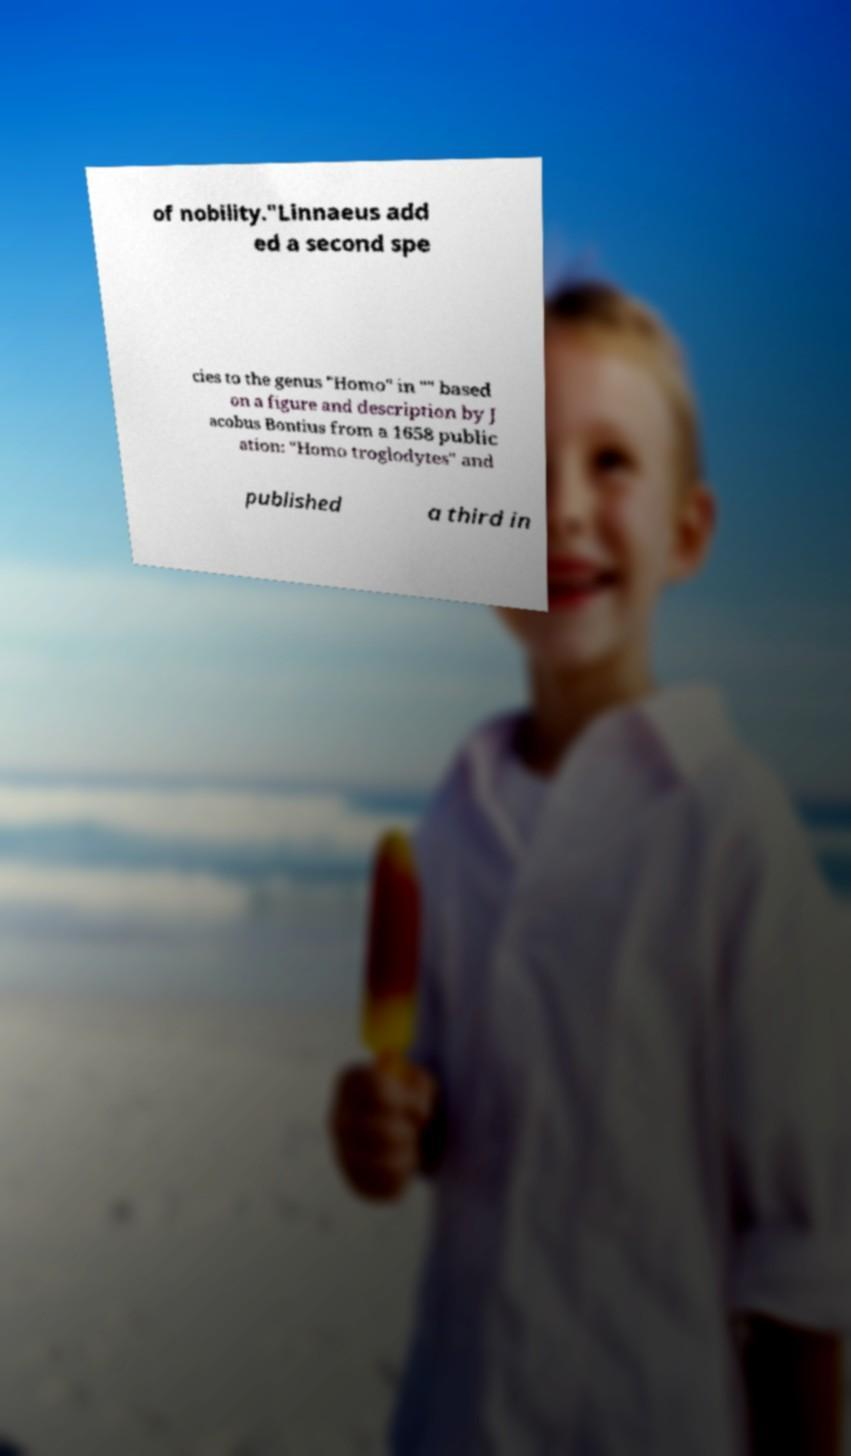Please read and relay the text visible in this image. What does it say? of nobility."Linnaeus add ed a second spe cies to the genus "Homo" in "" based on a figure and description by J acobus Bontius from a 1658 public ation: "Homo troglodytes" and published a third in 